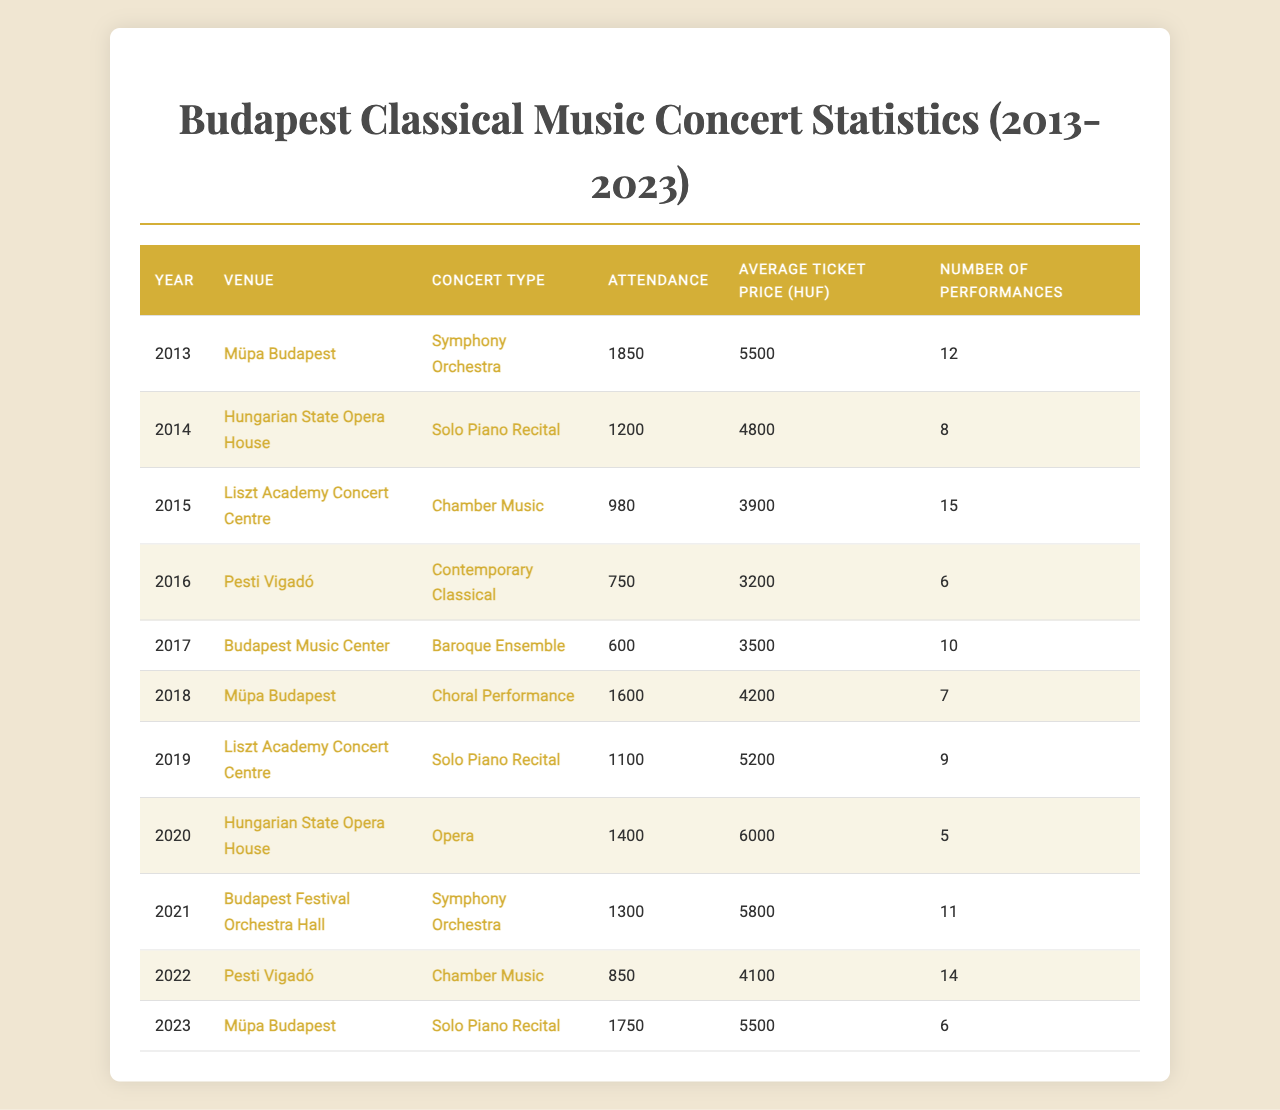What was the highest concert attendance in Budapest in the past decade? From the "Attendance" column, I review the numbers for each year and find that the highest value is 1850, recorded in 2013 at Müpa Budapest for a Symphony Orchestra performance.
Answer: 1850 Which concert type had the lowest average ticket price in the past decade? I look through the "Average Ticket Price (HUF)" column and identify the lowest ticket price, which is 3200 HUF for the Contemporary Classical concert held in 2016 at Pesti Vigadó.
Answer: Contemporary Classical How many performances were held across all venues in 2022? Referring to the "Number of Performances" column for 2022, there were 14 performances held at Pesti Vigadó classified as Chamber Music.
Answer: 14 What was the average attendance for Solo Piano Recitals over the past decade? I locate all attendance figures corresponding to Solo Piano Recitals: 1200 (2014) + 1100 (2019) + 1750 (2023) = 4050. There are 3 performances, so the average is 4050/3 = 1350.
Answer: 1350 Did the attendance for the Chamber Music performances ever exceed 1000? I check the attendance data specifically for Chamber Music performances: 980 (2015) and 850 (2022). Since both figures are below 1000, the answer is no.
Answer: No What percentage increase in attendance was seen from 2016's Contemporary Classical concert to 2018's Choral Performance? The attendance for 2016 was 750 and for 2018 was 1600. The increase is 1600 - 750 = 850. To find the percentage increase: (850/750) * 100 = 113.33%.
Answer: 113.33% Which venue had the highest attendance for a Symphony Orchestra concert? I check the "Venue" and "Concert Type" for Symphony Orchestra concerts and find that Müpa Budapest had the highest attendance of 1850 in 2013.
Answer: Müpa Budapest What was the total attendance for concerts in 2019? I look at the "Attendance" column for all concerts in 2019. There was 1100 in that year for Solo Piano Recital at Liszt Academy Concert Centre, so the total is 1100.
Answer: 1100 Was the average ticket price for the Hungarian State Opera House's performances higher than 5000 HUF in 2020? The average ticket price for the Opera performance at the Hungarian State Opera House in 2020 was 6000 HUF, which is indeed higher than 5000 HUF.
Answer: Yes How many concerts featured Baroque Ensemble performances, and what was their average ticket price? There was 1 performance in 2017 for Baroque Ensemble, with an average ticket price of 3500 HUF.
Answer: 1 concert, 3500 HUF What is the trend of concert attendance from 2013 to 2023? I look at the attendance figures: 1850, 1200, 980, 750, 600, 1600, 1100, 1400, 1300, and 850 for each year respectively. The trend shows fluctuating numbers, with a peak in 2013 and a decline to 600 in 2017 before rising again towards the most recent figure.
Answer: Fluctuating trend with a peak and a low point 